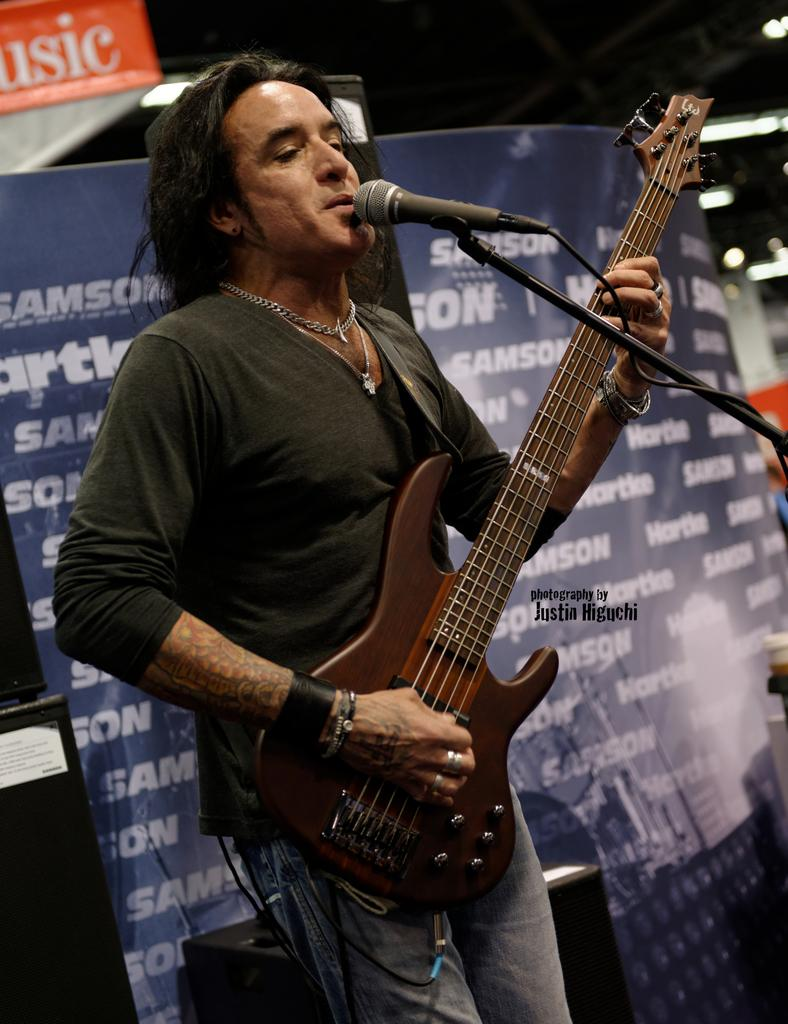What is the man in the image doing? The man is playing a guitar and singing. How is the man holding the guitar? The man is holding the guitar in his hands. What is the man using to amplify his voice? There is a microphone in front of the man. What can be seen in the background of the image? There is a poster in the background of the image. What type of magic is the man performing with the guitar in the image? There is no magic being performed in the image; the man is simply playing the guitar and singing. 